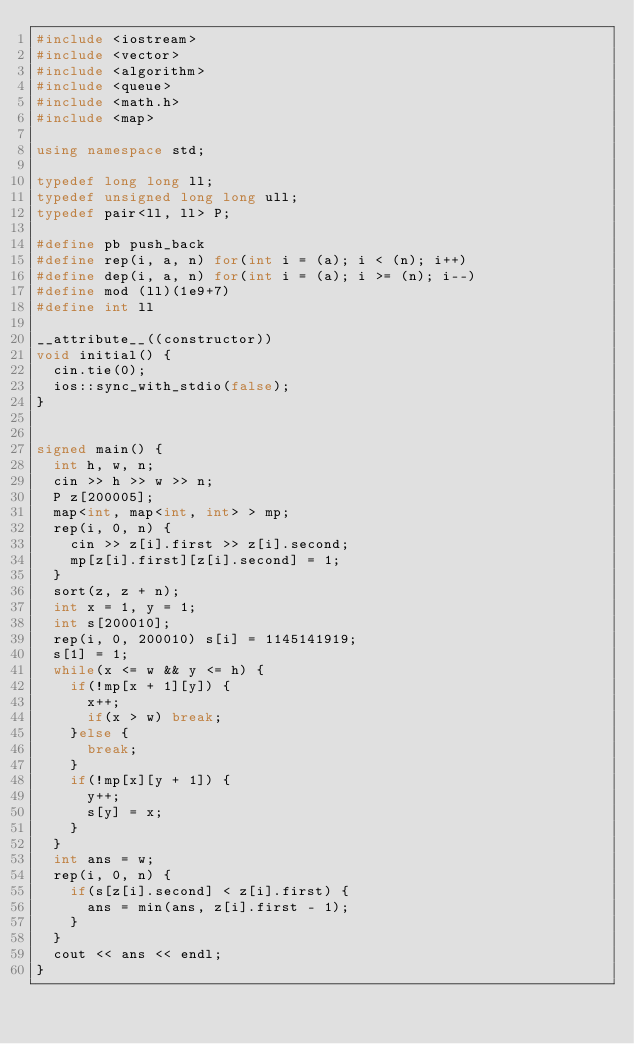<code> <loc_0><loc_0><loc_500><loc_500><_C++_>#include <iostream>
#include <vector>
#include <algorithm>
#include <queue>
#include <math.h>
#include <map>

using namespace std;

typedef long long ll;
typedef unsigned long long ull;
typedef pair<ll, ll> P;

#define pb push_back
#define rep(i, a, n) for(int i = (a); i < (n); i++)
#define dep(i, a, n) for(int i = (a); i >= (n); i--)
#define mod (ll)(1e9+7)
#define int ll

__attribute__((constructor))
void initial() {
  cin.tie(0);
  ios::sync_with_stdio(false);
}


signed main() {
  int h, w, n;
  cin >> h >> w >> n;
  P z[200005];
  map<int, map<int, int> > mp;
  rep(i, 0, n) {
    cin >> z[i].first >> z[i].second;
    mp[z[i].first][z[i].second] = 1;
  }
  sort(z, z + n);
  int x = 1, y = 1;
  int s[200010];
  rep(i, 0, 200010) s[i] = 1145141919;
  s[1] = 1;
  while(x <= w && y <= h) {
    if(!mp[x + 1][y]) {
      x++;
      if(x > w) break;
    }else {
      break;
    }
    if(!mp[x][y + 1]) {
      y++;
      s[y] = x;
    }
  }
  int ans = w;
  rep(i, 0, n) {
    if(s[z[i].second] < z[i].first) {
      ans = min(ans, z[i].first - 1);
    }
  }
  cout << ans << endl;
}
</code> 